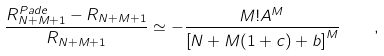<formula> <loc_0><loc_0><loc_500><loc_500>\frac { R ^ { P a d e } _ { N + M + 1 } - R _ { N + M + 1 } } { R _ { N + M + 1 } } \simeq - \frac { M ! A ^ { M } } { \left [ N + M ( 1 + c ) + b \right ] ^ { M } } \quad ,</formula> 